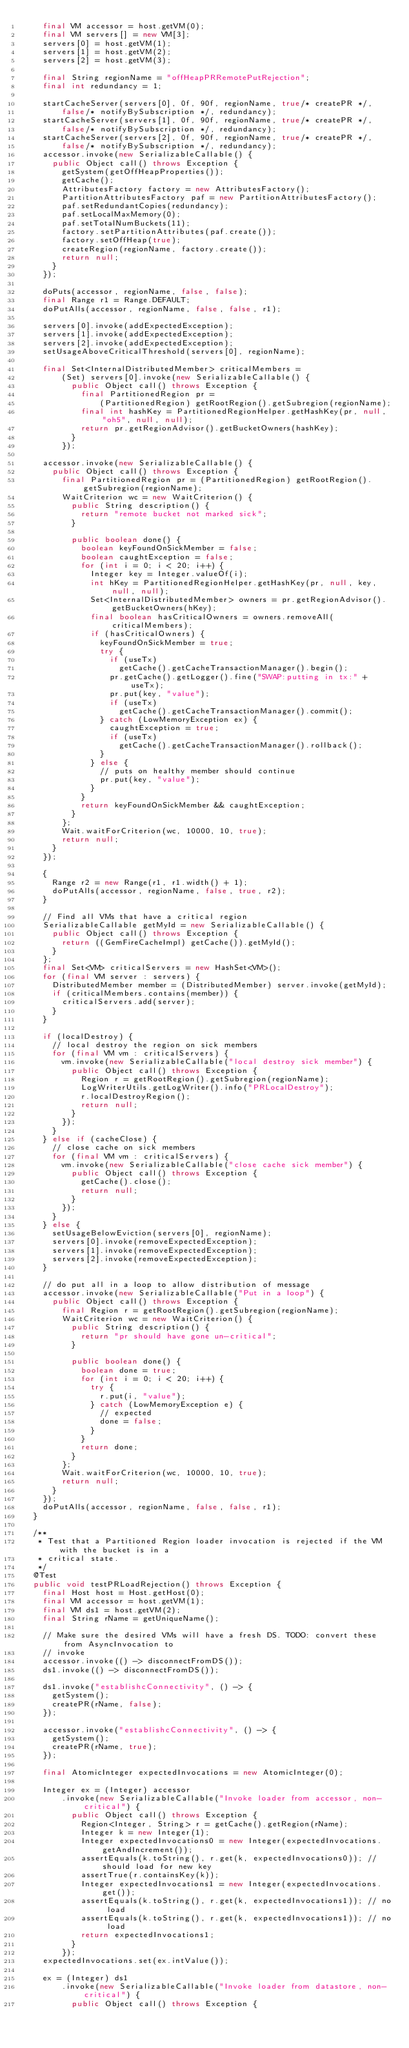Convert code to text. <code><loc_0><loc_0><loc_500><loc_500><_Java_>    final VM accessor = host.getVM(0);
    final VM servers[] = new VM[3];
    servers[0] = host.getVM(1);
    servers[1] = host.getVM(2);
    servers[2] = host.getVM(3);

    final String regionName = "offHeapPRRemotePutRejection";
    final int redundancy = 1;

    startCacheServer(servers[0], 0f, 90f, regionName, true/* createPR */,
        false/* notifyBySubscription */, redundancy);
    startCacheServer(servers[1], 0f, 90f, regionName, true/* createPR */,
        false/* notifyBySubscription */, redundancy);
    startCacheServer(servers[2], 0f, 90f, regionName, true/* createPR */,
        false/* notifyBySubscription */, redundancy);
    accessor.invoke(new SerializableCallable() {
      public Object call() throws Exception {
        getSystem(getOffHeapProperties());
        getCache();
        AttributesFactory factory = new AttributesFactory();
        PartitionAttributesFactory paf = new PartitionAttributesFactory();
        paf.setRedundantCopies(redundancy);
        paf.setLocalMaxMemory(0);
        paf.setTotalNumBuckets(11);
        factory.setPartitionAttributes(paf.create());
        factory.setOffHeap(true);
        createRegion(regionName, factory.create());
        return null;
      }
    });

    doPuts(accessor, regionName, false, false);
    final Range r1 = Range.DEFAULT;
    doPutAlls(accessor, regionName, false, false, r1);

    servers[0].invoke(addExpectedException);
    servers[1].invoke(addExpectedException);
    servers[2].invoke(addExpectedException);
    setUsageAboveCriticalThreshold(servers[0], regionName);

    final Set<InternalDistributedMember> criticalMembers =
        (Set) servers[0].invoke(new SerializableCallable() {
          public Object call() throws Exception {
            final PartitionedRegion pr =
                (PartitionedRegion) getRootRegion().getSubregion(regionName);
            final int hashKey = PartitionedRegionHelper.getHashKey(pr, null, "oh5", null, null);
            return pr.getRegionAdvisor().getBucketOwners(hashKey);
          }
        });

    accessor.invoke(new SerializableCallable() {
      public Object call() throws Exception {
        final PartitionedRegion pr = (PartitionedRegion) getRootRegion().getSubregion(regionName);
        WaitCriterion wc = new WaitCriterion() {
          public String description() {
            return "remote bucket not marked sick";
          }

          public boolean done() {
            boolean keyFoundOnSickMember = false;
            boolean caughtException = false;
            for (int i = 0; i < 20; i++) {
              Integer key = Integer.valueOf(i);
              int hKey = PartitionedRegionHelper.getHashKey(pr, null, key, null, null);
              Set<InternalDistributedMember> owners = pr.getRegionAdvisor().getBucketOwners(hKey);
              final boolean hasCriticalOwners = owners.removeAll(criticalMembers);
              if (hasCriticalOwners) {
                keyFoundOnSickMember = true;
                try {
                  if (useTx)
                    getCache().getCacheTransactionManager().begin();
                  pr.getCache().getLogger().fine("SWAP:putting in tx:" + useTx);
                  pr.put(key, "value");
                  if (useTx)
                    getCache().getCacheTransactionManager().commit();
                } catch (LowMemoryException ex) {
                  caughtException = true;
                  if (useTx)
                    getCache().getCacheTransactionManager().rollback();
                }
              } else {
                // puts on healthy member should continue
                pr.put(key, "value");
              }
            }
            return keyFoundOnSickMember && caughtException;
          }
        };
        Wait.waitForCriterion(wc, 10000, 10, true);
        return null;
      }
    });

    {
      Range r2 = new Range(r1, r1.width() + 1);
      doPutAlls(accessor, regionName, false, true, r2);
    }

    // Find all VMs that have a critical region
    SerializableCallable getMyId = new SerializableCallable() {
      public Object call() throws Exception {
        return ((GemFireCacheImpl) getCache()).getMyId();
      }
    };
    final Set<VM> criticalServers = new HashSet<VM>();
    for (final VM server : servers) {
      DistributedMember member = (DistributedMember) server.invoke(getMyId);
      if (criticalMembers.contains(member)) {
        criticalServers.add(server);
      }
    }

    if (localDestroy) {
      // local destroy the region on sick members
      for (final VM vm : criticalServers) {
        vm.invoke(new SerializableCallable("local destroy sick member") {
          public Object call() throws Exception {
            Region r = getRootRegion().getSubregion(regionName);
            LogWriterUtils.getLogWriter().info("PRLocalDestroy");
            r.localDestroyRegion();
            return null;
          }
        });
      }
    } else if (cacheClose) {
      // close cache on sick members
      for (final VM vm : criticalServers) {
        vm.invoke(new SerializableCallable("close cache sick member") {
          public Object call() throws Exception {
            getCache().close();
            return null;
          }
        });
      }
    } else {
      setUsageBelowEviction(servers[0], regionName);
      servers[0].invoke(removeExpectedException);
      servers[1].invoke(removeExpectedException);
      servers[2].invoke(removeExpectedException);
    }

    // do put all in a loop to allow distribution of message
    accessor.invoke(new SerializableCallable("Put in a loop") {
      public Object call() throws Exception {
        final Region r = getRootRegion().getSubregion(regionName);
        WaitCriterion wc = new WaitCriterion() {
          public String description() {
            return "pr should have gone un-critical";
          }

          public boolean done() {
            boolean done = true;
            for (int i = 0; i < 20; i++) {
              try {
                r.put(i, "value");
              } catch (LowMemoryException e) {
                // expected
                done = false;
              }
            }
            return done;
          }
        };
        Wait.waitForCriterion(wc, 10000, 10, true);
        return null;
      }
    });
    doPutAlls(accessor, regionName, false, false, r1);
  }

  /**
   * Test that a Partitioned Region loader invocation is rejected if the VM with the bucket is in a
   * critical state.
   */
  @Test
  public void testPRLoadRejection() throws Exception {
    final Host host = Host.getHost(0);
    final VM accessor = host.getVM(1);
    final VM ds1 = host.getVM(2);
    final String rName = getUniqueName();

    // Make sure the desired VMs will have a fresh DS. TODO: convert these from AsyncInvocation to
    // invoke
    accessor.invoke(() -> disconnectFromDS());
    ds1.invoke(() -> disconnectFromDS());

    ds1.invoke("establishcConnectivity", () -> {
      getSystem();
      createPR(rName, false);
    });

    accessor.invoke("establishcConnectivity", () -> {
      getSystem();
      createPR(rName, true);
    });

    final AtomicInteger expectedInvocations = new AtomicInteger(0);

    Integer ex = (Integer) accessor
        .invoke(new SerializableCallable("Invoke loader from accessor, non-critical") {
          public Object call() throws Exception {
            Region<Integer, String> r = getCache().getRegion(rName);
            Integer k = new Integer(1);
            Integer expectedInvocations0 = new Integer(expectedInvocations.getAndIncrement());
            assertEquals(k.toString(), r.get(k, expectedInvocations0)); // should load for new key
            assertTrue(r.containsKey(k));
            Integer expectedInvocations1 = new Integer(expectedInvocations.get());
            assertEquals(k.toString(), r.get(k, expectedInvocations1)); // no load
            assertEquals(k.toString(), r.get(k, expectedInvocations1)); // no load
            return expectedInvocations1;
          }
        });
    expectedInvocations.set(ex.intValue());

    ex = (Integer) ds1
        .invoke(new SerializableCallable("Invoke loader from datastore, non-critical") {
          public Object call() throws Exception {</code> 